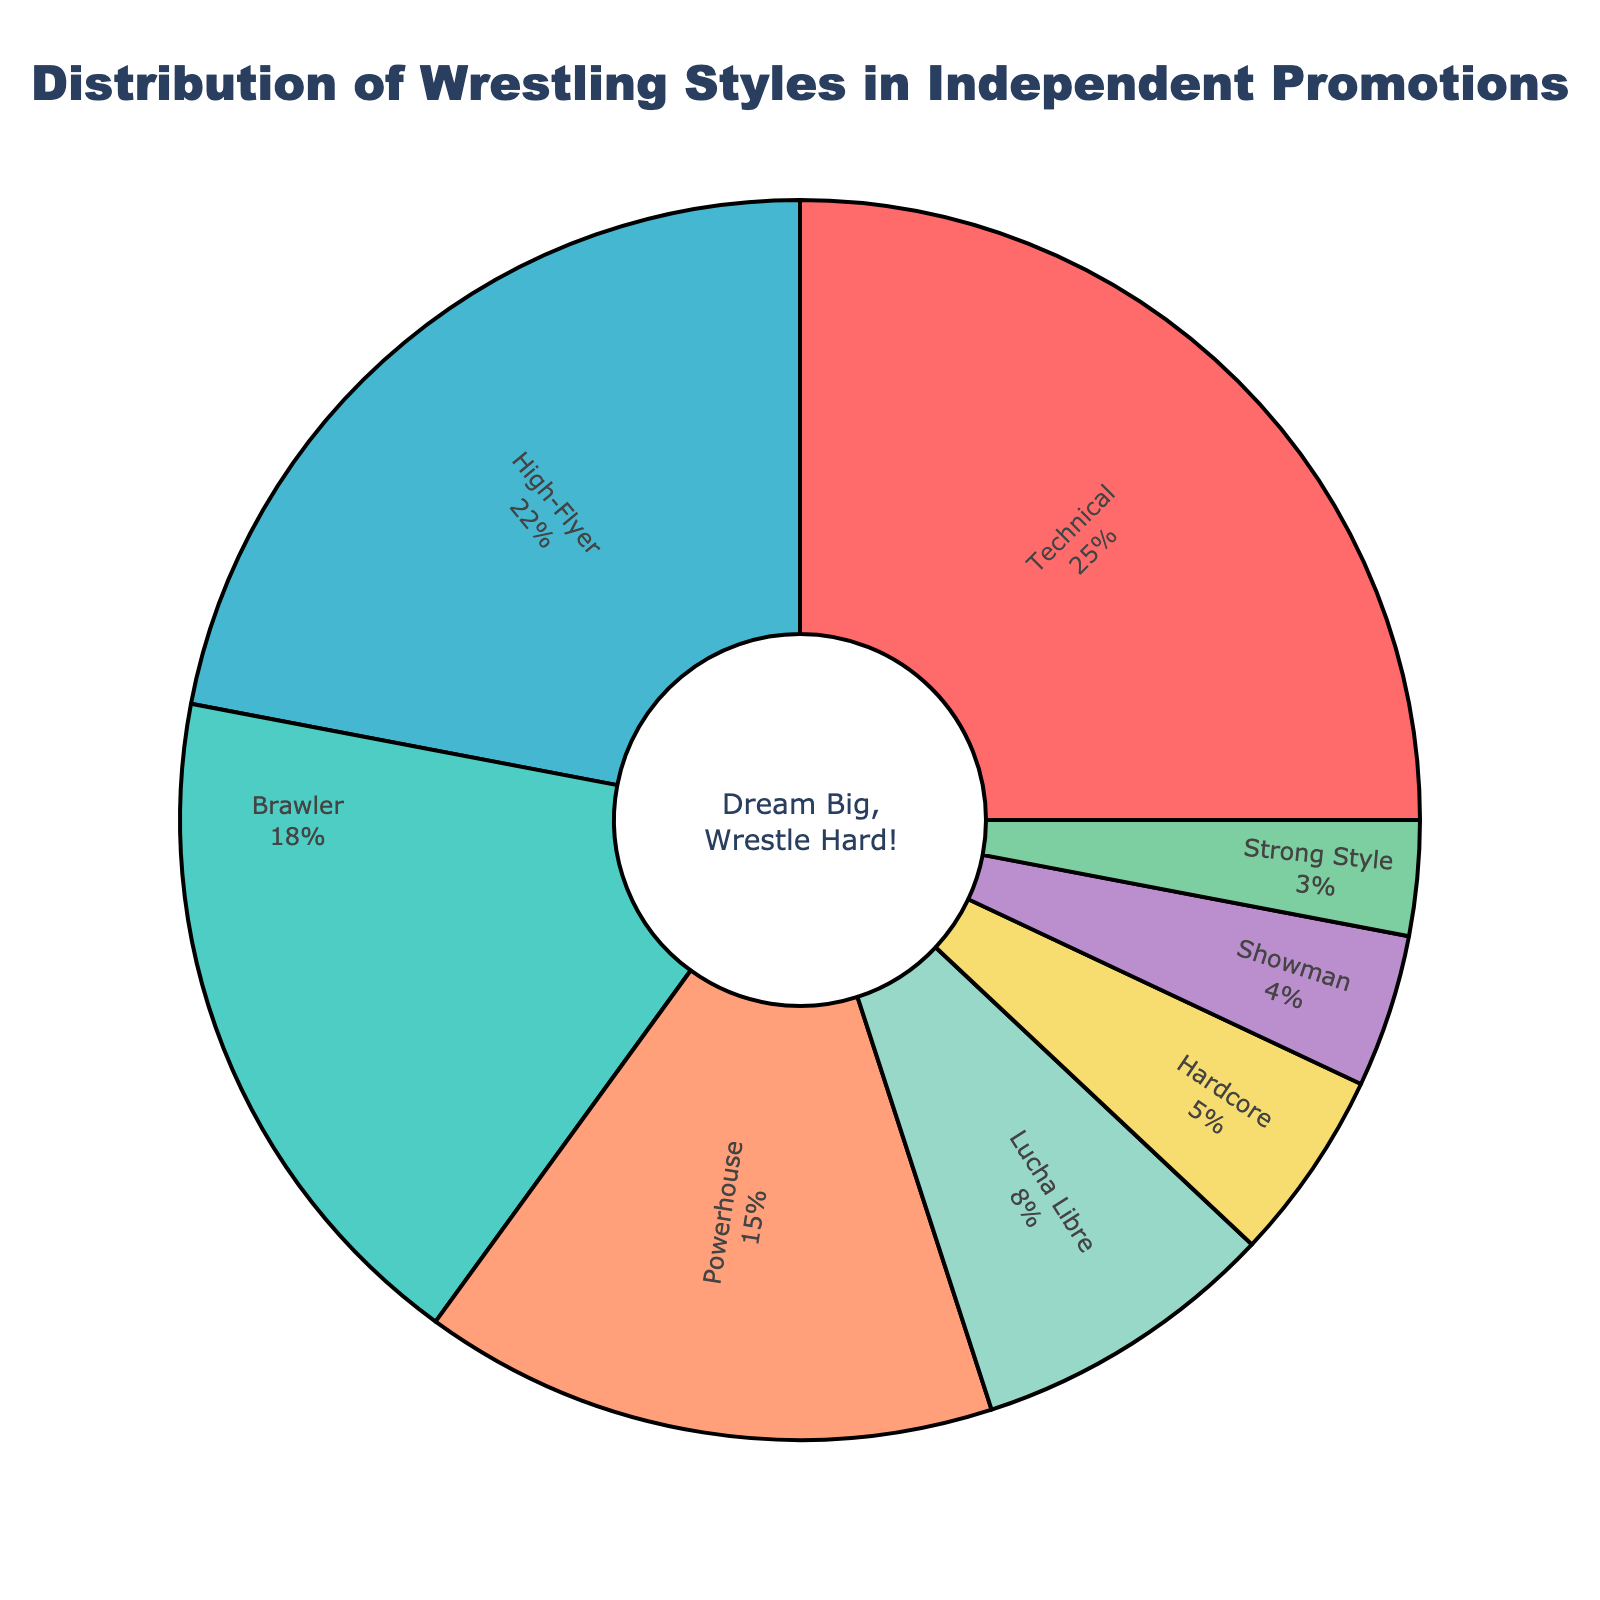What's the most common wrestling style in independent promotions? The pie chart shows different wrestling styles with their respective percentages. The highest percentage corresponds to the most common style. Technical wrestling has the highest percentage at 25%.
Answer: Technical What's the combined percentage of High-Flyer and Powerhouse styles? To find the combined percentage, add the percentage for High-Flyer (22%) and Powerhouse (15%). 22% + 15% = 37%.
Answer: 37% How much more prevalent is the Technical style compared to the Lucha Libre style? The percentage for Technical style is 25%, and for Lucha Libre, it's 8%. The difference is 25% - 8% = 17%.
Answer: 17% What percentage of wrestling styles fall below 10%? Styles with percentages below 10% are Lucha Libre (8%), Hardcore (5%), Showman (4%), and Strong Style (3%). Adding these gives 8% + 5% + 4% + 3% = 20%.
Answer: 20% Which wrestling style is represented by the color red? Observing the color used in the pie chart, the red section corresponds to the Technical wrestling style.
Answer: Technical What is the percentage difference between Brawler and Hardcore styles? Brawler style has a percentage of 18%, and Hardcore style has 5%. The difference is 18% - 5% = 13%.
Answer: 13% Which two styles have almost the same percentage, and what are those percentages? The percentages for High-Flyer (22%) and Technical (25%) are close to each other but not almost the same. The better match is Brawler (18%) and Powerhouse (15%), but they are also not close enough. The closest pair is probably more subjective.
Answer: Not closely matched pairs How much percentage do the least three prevalent styles add up to? The least three prevalent styles are Strong Style (3%), Showman (4%), and Hardcore (5%). Adding these gives 3% + 4% + 5% = 12%.
Answer: 12% What percentage of styles are represented by the green color? The pie chart uses green shades for different styles. The green color is likely for the Brawler style, which is 18%. Different shades might mislead; double-check specific green identifiers if provided visually.
Answer: 18% (if exact match used) Which is more common, High-Flyer or Powerhouse wrestling style? Comparing the percentages, High-Flyer is 22% and Powerhouse is 15%. High-Flyer is more common.
Answer: High-Flyer 